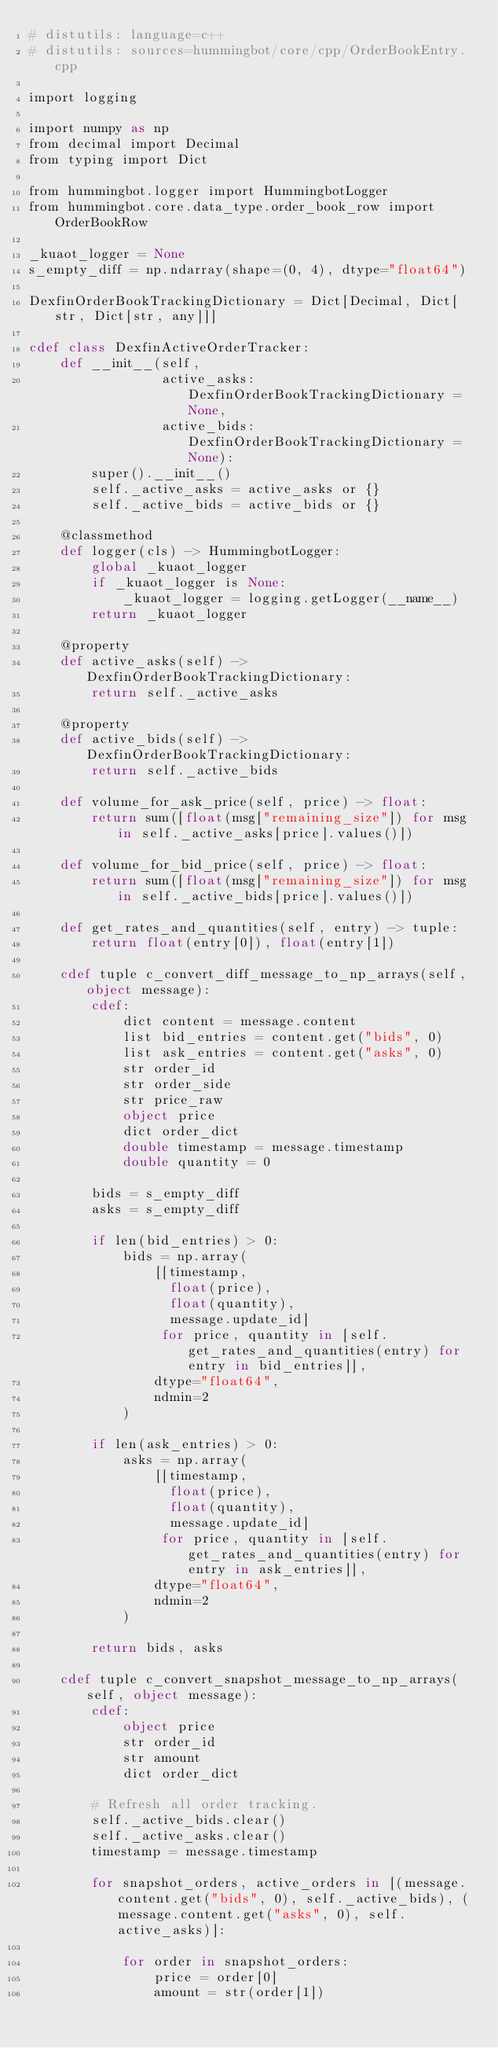<code> <loc_0><loc_0><loc_500><loc_500><_Cython_># distutils: language=c++
# distutils: sources=hummingbot/core/cpp/OrderBookEntry.cpp

import logging

import numpy as np
from decimal import Decimal
from typing import Dict

from hummingbot.logger import HummingbotLogger
from hummingbot.core.data_type.order_book_row import OrderBookRow

_kuaot_logger = None
s_empty_diff = np.ndarray(shape=(0, 4), dtype="float64")

DexfinOrderBookTrackingDictionary = Dict[Decimal, Dict[str, Dict[str, any]]]

cdef class DexfinActiveOrderTracker:
    def __init__(self,
                 active_asks: DexfinOrderBookTrackingDictionary = None,
                 active_bids: DexfinOrderBookTrackingDictionary = None):
        super().__init__()
        self._active_asks = active_asks or {}
        self._active_bids = active_bids or {}

    @classmethod
    def logger(cls) -> HummingbotLogger:
        global _kuaot_logger
        if _kuaot_logger is None:
            _kuaot_logger = logging.getLogger(__name__)
        return _kuaot_logger

    @property
    def active_asks(self) -> DexfinOrderBookTrackingDictionary:
        return self._active_asks

    @property
    def active_bids(self) -> DexfinOrderBookTrackingDictionary:
        return self._active_bids

    def volume_for_ask_price(self, price) -> float:
        return sum([float(msg["remaining_size"]) for msg in self._active_asks[price].values()])

    def volume_for_bid_price(self, price) -> float:
        return sum([float(msg["remaining_size"]) for msg in self._active_bids[price].values()])

    def get_rates_and_quantities(self, entry) -> tuple:
        return float(entry[0]), float(entry[1])

    cdef tuple c_convert_diff_message_to_np_arrays(self, object message):
        cdef:
            dict content = message.content
            list bid_entries = content.get("bids", 0)
            list ask_entries = content.get("asks", 0)
            str order_id
            str order_side
            str price_raw
            object price
            dict order_dict
            double timestamp = message.timestamp
            double quantity = 0

        bids = s_empty_diff
        asks = s_empty_diff

        if len(bid_entries) > 0:
            bids = np.array(
                [[timestamp,
                  float(price),
                  float(quantity),
                  message.update_id]
                 for price, quantity in [self.get_rates_and_quantities(entry) for entry in bid_entries]],
                dtype="float64",
                ndmin=2
            )

        if len(ask_entries) > 0:
            asks = np.array(
                [[timestamp,
                  float(price),
                  float(quantity),
                  message.update_id]
                 for price, quantity in [self.get_rates_and_quantities(entry) for entry in ask_entries]],
                dtype="float64",
                ndmin=2
            )

        return bids, asks

    cdef tuple c_convert_snapshot_message_to_np_arrays(self, object message):
        cdef:
            object price
            str order_id
            str amount
            dict order_dict

        # Refresh all order tracking.
        self._active_bids.clear()
        self._active_asks.clear()
        timestamp = message.timestamp

        for snapshot_orders, active_orders in [(message.content.get("bids", 0), self._active_bids), (message.content.get("asks", 0), self.active_asks)]:

            for order in snapshot_orders:
                price = order[0]
                amount = str(order[1])</code> 